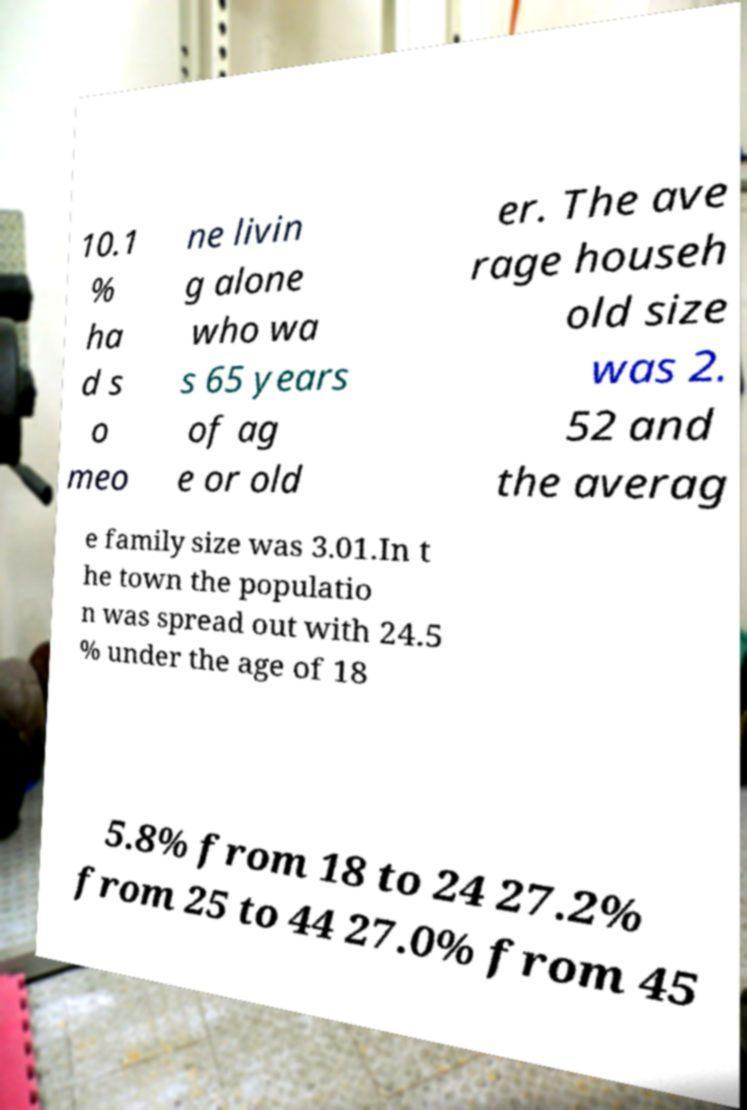Can you read and provide the text displayed in the image?This photo seems to have some interesting text. Can you extract and type it out for me? 10.1 % ha d s o meo ne livin g alone who wa s 65 years of ag e or old er. The ave rage househ old size was 2. 52 and the averag e family size was 3.01.In t he town the populatio n was spread out with 24.5 % under the age of 18 5.8% from 18 to 24 27.2% from 25 to 44 27.0% from 45 